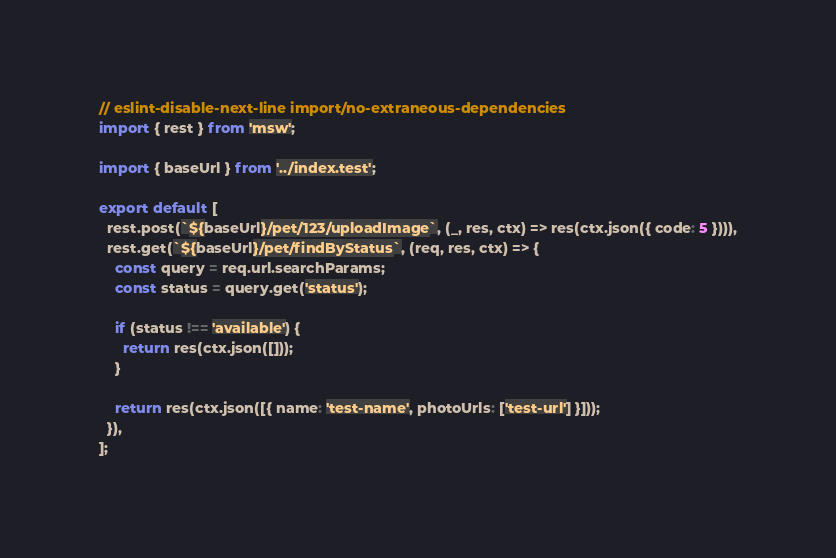<code> <loc_0><loc_0><loc_500><loc_500><_TypeScript_>// eslint-disable-next-line import/no-extraneous-dependencies
import { rest } from 'msw';

import { baseUrl } from '../index.test';

export default [
  rest.post(`${baseUrl}/pet/123/uploadImage`, (_, res, ctx) => res(ctx.json({ code: 5 }))),
  rest.get(`${baseUrl}/pet/findByStatus`, (req, res, ctx) => {
    const query = req.url.searchParams;
    const status = query.get('status');

    if (status !== 'available') {
      return res(ctx.json([]));
    }

    return res(ctx.json([{ name: 'test-name', photoUrls: ['test-url'] }]));
  }),
];
</code> 